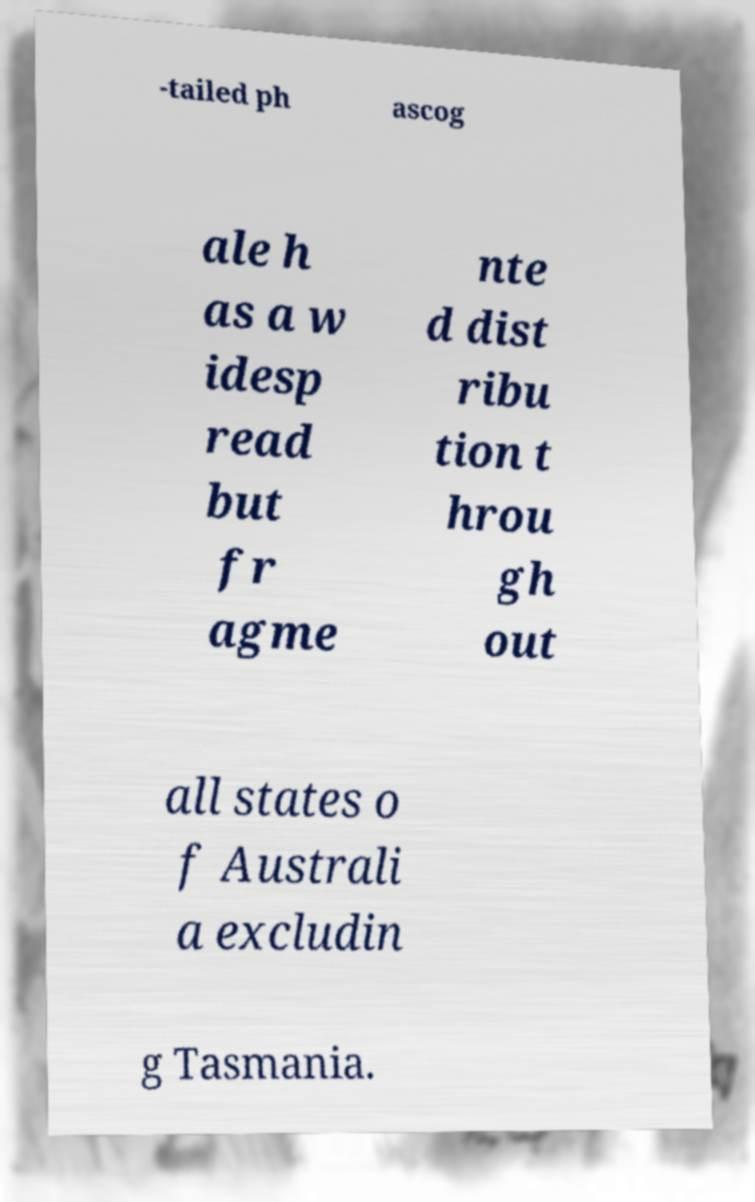Please read and relay the text visible in this image. What does it say? -tailed ph ascog ale h as a w idesp read but fr agme nte d dist ribu tion t hrou gh out all states o f Australi a excludin g Tasmania. 